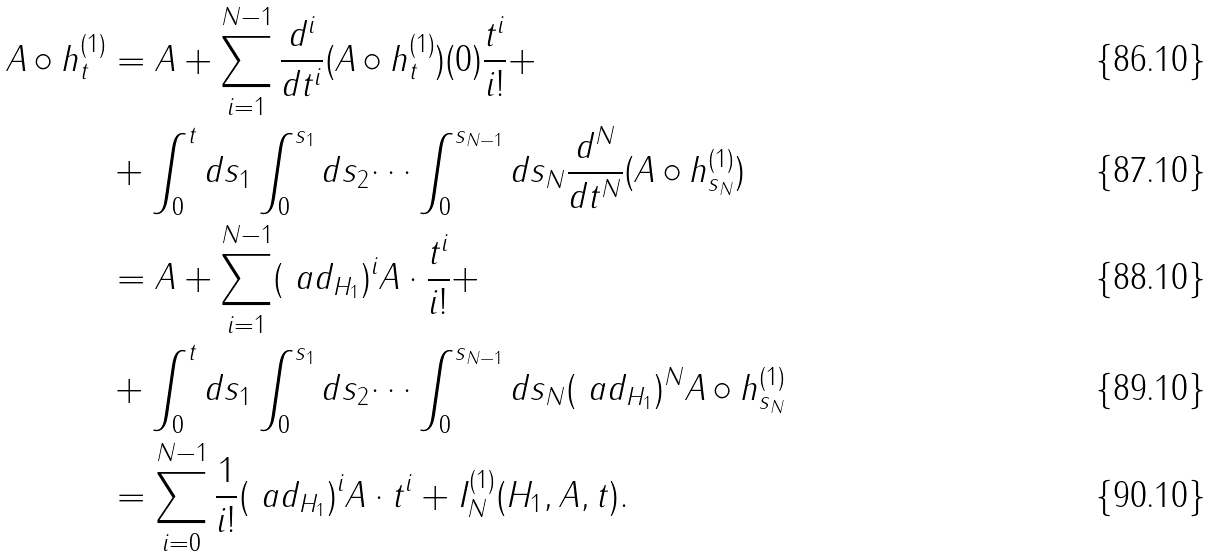Convert formula to latex. <formula><loc_0><loc_0><loc_500><loc_500>A \circ h _ { t } ^ { ( 1 ) } & = A + \sum _ { i = 1 } ^ { N - 1 } \frac { d ^ { i } } { d t ^ { i } } ( A \circ h _ { t } ^ { ( 1 ) } ) ( 0 ) \frac { t ^ { i } } { i ! } + \\ & + \int _ { 0 } ^ { t } d s _ { 1 } \int _ { 0 } ^ { s _ { 1 } } d s _ { 2 } \dots \int _ { 0 } ^ { s _ { N - 1 } } d s _ { N } \frac { d ^ { N } } { d t ^ { N } } ( A \circ h _ { s _ { N } } ^ { ( 1 ) } ) \\ & = A + \sum _ { i = 1 } ^ { N - 1 } ( \ a d _ { H _ { 1 } } ) ^ { i } A \cdot \frac { t ^ { i } } { i ! } + \\ & + \int _ { 0 } ^ { t } d s _ { 1 } \int _ { 0 } ^ { s _ { 1 } } d s _ { 2 } \dots \int _ { 0 } ^ { s _ { N - 1 } } d s _ { N } ( \ a d _ { H _ { 1 } } ) ^ { N } A \circ h _ { s _ { N } } ^ { ( 1 ) } \\ & = \sum _ { i = 0 } ^ { N - 1 } \frac { 1 } { i ! } ( \ a d _ { H _ { 1 } } ) ^ { i } A \cdot t ^ { i } + I _ { N } ^ { ( 1 ) } ( H _ { 1 } , A , t ) .</formula> 